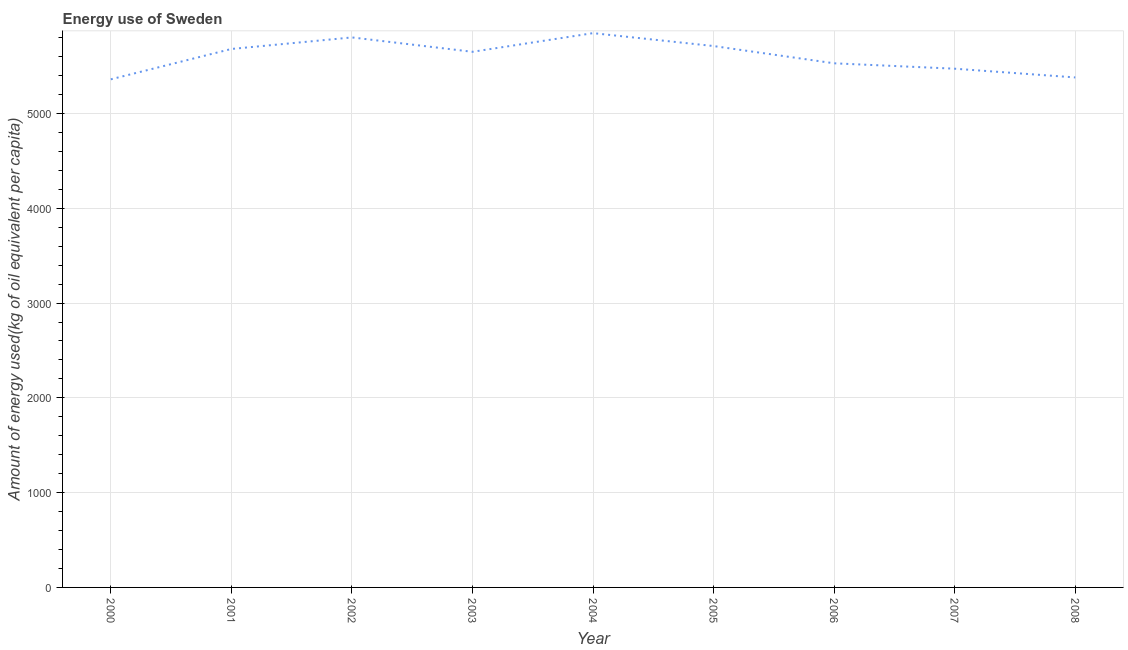What is the amount of energy used in 2005?
Your answer should be compact. 5711.13. Across all years, what is the maximum amount of energy used?
Keep it short and to the point. 5847.34. Across all years, what is the minimum amount of energy used?
Ensure brevity in your answer.  5360.15. In which year was the amount of energy used maximum?
Offer a terse response. 2004. What is the sum of the amount of energy used?
Offer a terse response. 5.04e+04. What is the difference between the amount of energy used in 2003 and 2005?
Ensure brevity in your answer.  -60.69. What is the average amount of energy used per year?
Your answer should be very brief. 5603.62. What is the median amount of energy used?
Offer a very short reply. 5650.44. Do a majority of the years between 2004 and 2005 (inclusive) have amount of energy used greater than 5400 kg?
Keep it short and to the point. Yes. What is the ratio of the amount of energy used in 2004 to that in 2008?
Make the answer very short. 1.09. Is the difference between the amount of energy used in 2005 and 2008 greater than the difference between any two years?
Keep it short and to the point. No. What is the difference between the highest and the second highest amount of energy used?
Provide a succinct answer. 45.23. What is the difference between the highest and the lowest amount of energy used?
Offer a terse response. 487.2. In how many years, is the amount of energy used greater than the average amount of energy used taken over all years?
Make the answer very short. 5. How many lines are there?
Provide a short and direct response. 1. Does the graph contain grids?
Keep it short and to the point. Yes. What is the title of the graph?
Your answer should be very brief. Energy use of Sweden. What is the label or title of the Y-axis?
Offer a terse response. Amount of energy used(kg of oil equivalent per capita). What is the Amount of energy used(kg of oil equivalent per capita) in 2000?
Keep it short and to the point. 5360.15. What is the Amount of energy used(kg of oil equivalent per capita) in 2001?
Give a very brief answer. 5680.28. What is the Amount of energy used(kg of oil equivalent per capita) of 2002?
Ensure brevity in your answer.  5802.11. What is the Amount of energy used(kg of oil equivalent per capita) in 2003?
Give a very brief answer. 5650.44. What is the Amount of energy used(kg of oil equivalent per capita) of 2004?
Keep it short and to the point. 5847.34. What is the Amount of energy used(kg of oil equivalent per capita) of 2005?
Your response must be concise. 5711.13. What is the Amount of energy used(kg of oil equivalent per capita) of 2006?
Provide a short and direct response. 5529.08. What is the Amount of energy used(kg of oil equivalent per capita) in 2007?
Your answer should be very brief. 5472.14. What is the Amount of energy used(kg of oil equivalent per capita) of 2008?
Make the answer very short. 5379.96. What is the difference between the Amount of energy used(kg of oil equivalent per capita) in 2000 and 2001?
Provide a short and direct response. -320.14. What is the difference between the Amount of energy used(kg of oil equivalent per capita) in 2000 and 2002?
Give a very brief answer. -441.96. What is the difference between the Amount of energy used(kg of oil equivalent per capita) in 2000 and 2003?
Keep it short and to the point. -290.29. What is the difference between the Amount of energy used(kg of oil equivalent per capita) in 2000 and 2004?
Keep it short and to the point. -487.2. What is the difference between the Amount of energy used(kg of oil equivalent per capita) in 2000 and 2005?
Make the answer very short. -350.98. What is the difference between the Amount of energy used(kg of oil equivalent per capita) in 2000 and 2006?
Your answer should be compact. -168.93. What is the difference between the Amount of energy used(kg of oil equivalent per capita) in 2000 and 2007?
Your response must be concise. -111.99. What is the difference between the Amount of energy used(kg of oil equivalent per capita) in 2000 and 2008?
Provide a short and direct response. -19.81. What is the difference between the Amount of energy used(kg of oil equivalent per capita) in 2001 and 2002?
Your answer should be compact. -121.83. What is the difference between the Amount of energy used(kg of oil equivalent per capita) in 2001 and 2003?
Keep it short and to the point. 29.84. What is the difference between the Amount of energy used(kg of oil equivalent per capita) in 2001 and 2004?
Your response must be concise. -167.06. What is the difference between the Amount of energy used(kg of oil equivalent per capita) in 2001 and 2005?
Offer a terse response. -30.85. What is the difference between the Amount of energy used(kg of oil equivalent per capita) in 2001 and 2006?
Make the answer very short. 151.2. What is the difference between the Amount of energy used(kg of oil equivalent per capita) in 2001 and 2007?
Give a very brief answer. 208.15. What is the difference between the Amount of energy used(kg of oil equivalent per capita) in 2001 and 2008?
Your answer should be compact. 300.32. What is the difference between the Amount of energy used(kg of oil equivalent per capita) in 2002 and 2003?
Your response must be concise. 151.67. What is the difference between the Amount of energy used(kg of oil equivalent per capita) in 2002 and 2004?
Your response must be concise. -45.23. What is the difference between the Amount of energy used(kg of oil equivalent per capita) in 2002 and 2005?
Provide a short and direct response. 90.98. What is the difference between the Amount of energy used(kg of oil equivalent per capita) in 2002 and 2006?
Offer a very short reply. 273.03. What is the difference between the Amount of energy used(kg of oil equivalent per capita) in 2002 and 2007?
Make the answer very short. 329.97. What is the difference between the Amount of energy used(kg of oil equivalent per capita) in 2002 and 2008?
Offer a terse response. 422.15. What is the difference between the Amount of energy used(kg of oil equivalent per capita) in 2003 and 2004?
Offer a very short reply. -196.91. What is the difference between the Amount of energy used(kg of oil equivalent per capita) in 2003 and 2005?
Offer a terse response. -60.69. What is the difference between the Amount of energy used(kg of oil equivalent per capita) in 2003 and 2006?
Provide a short and direct response. 121.36. What is the difference between the Amount of energy used(kg of oil equivalent per capita) in 2003 and 2007?
Your answer should be compact. 178.3. What is the difference between the Amount of energy used(kg of oil equivalent per capita) in 2003 and 2008?
Your response must be concise. 270.48. What is the difference between the Amount of energy used(kg of oil equivalent per capita) in 2004 and 2005?
Make the answer very short. 136.22. What is the difference between the Amount of energy used(kg of oil equivalent per capita) in 2004 and 2006?
Make the answer very short. 318.27. What is the difference between the Amount of energy used(kg of oil equivalent per capita) in 2004 and 2007?
Provide a succinct answer. 375.21. What is the difference between the Amount of energy used(kg of oil equivalent per capita) in 2004 and 2008?
Ensure brevity in your answer.  467.39. What is the difference between the Amount of energy used(kg of oil equivalent per capita) in 2005 and 2006?
Your answer should be very brief. 182.05. What is the difference between the Amount of energy used(kg of oil equivalent per capita) in 2005 and 2007?
Your answer should be very brief. 238.99. What is the difference between the Amount of energy used(kg of oil equivalent per capita) in 2005 and 2008?
Make the answer very short. 331.17. What is the difference between the Amount of energy used(kg of oil equivalent per capita) in 2006 and 2007?
Your answer should be compact. 56.94. What is the difference between the Amount of energy used(kg of oil equivalent per capita) in 2006 and 2008?
Make the answer very short. 149.12. What is the difference between the Amount of energy used(kg of oil equivalent per capita) in 2007 and 2008?
Offer a terse response. 92.18. What is the ratio of the Amount of energy used(kg of oil equivalent per capita) in 2000 to that in 2001?
Your response must be concise. 0.94. What is the ratio of the Amount of energy used(kg of oil equivalent per capita) in 2000 to that in 2002?
Keep it short and to the point. 0.92. What is the ratio of the Amount of energy used(kg of oil equivalent per capita) in 2000 to that in 2003?
Keep it short and to the point. 0.95. What is the ratio of the Amount of energy used(kg of oil equivalent per capita) in 2000 to that in 2004?
Provide a short and direct response. 0.92. What is the ratio of the Amount of energy used(kg of oil equivalent per capita) in 2000 to that in 2005?
Your response must be concise. 0.94. What is the ratio of the Amount of energy used(kg of oil equivalent per capita) in 2000 to that in 2007?
Provide a short and direct response. 0.98. What is the ratio of the Amount of energy used(kg of oil equivalent per capita) in 2001 to that in 2004?
Keep it short and to the point. 0.97. What is the ratio of the Amount of energy used(kg of oil equivalent per capita) in 2001 to that in 2005?
Keep it short and to the point. 0.99. What is the ratio of the Amount of energy used(kg of oil equivalent per capita) in 2001 to that in 2007?
Keep it short and to the point. 1.04. What is the ratio of the Amount of energy used(kg of oil equivalent per capita) in 2001 to that in 2008?
Make the answer very short. 1.06. What is the ratio of the Amount of energy used(kg of oil equivalent per capita) in 2002 to that in 2004?
Make the answer very short. 0.99. What is the ratio of the Amount of energy used(kg of oil equivalent per capita) in 2002 to that in 2006?
Your answer should be very brief. 1.05. What is the ratio of the Amount of energy used(kg of oil equivalent per capita) in 2002 to that in 2007?
Your answer should be compact. 1.06. What is the ratio of the Amount of energy used(kg of oil equivalent per capita) in 2002 to that in 2008?
Give a very brief answer. 1.08. What is the ratio of the Amount of energy used(kg of oil equivalent per capita) in 2003 to that in 2007?
Your answer should be compact. 1.03. What is the ratio of the Amount of energy used(kg of oil equivalent per capita) in 2003 to that in 2008?
Provide a succinct answer. 1.05. What is the ratio of the Amount of energy used(kg of oil equivalent per capita) in 2004 to that in 2005?
Offer a terse response. 1.02. What is the ratio of the Amount of energy used(kg of oil equivalent per capita) in 2004 to that in 2006?
Your answer should be compact. 1.06. What is the ratio of the Amount of energy used(kg of oil equivalent per capita) in 2004 to that in 2007?
Offer a very short reply. 1.07. What is the ratio of the Amount of energy used(kg of oil equivalent per capita) in 2004 to that in 2008?
Ensure brevity in your answer.  1.09. What is the ratio of the Amount of energy used(kg of oil equivalent per capita) in 2005 to that in 2006?
Provide a short and direct response. 1.03. What is the ratio of the Amount of energy used(kg of oil equivalent per capita) in 2005 to that in 2007?
Keep it short and to the point. 1.04. What is the ratio of the Amount of energy used(kg of oil equivalent per capita) in 2005 to that in 2008?
Offer a terse response. 1.06. What is the ratio of the Amount of energy used(kg of oil equivalent per capita) in 2006 to that in 2007?
Your answer should be very brief. 1.01. What is the ratio of the Amount of energy used(kg of oil equivalent per capita) in 2006 to that in 2008?
Your answer should be compact. 1.03. 